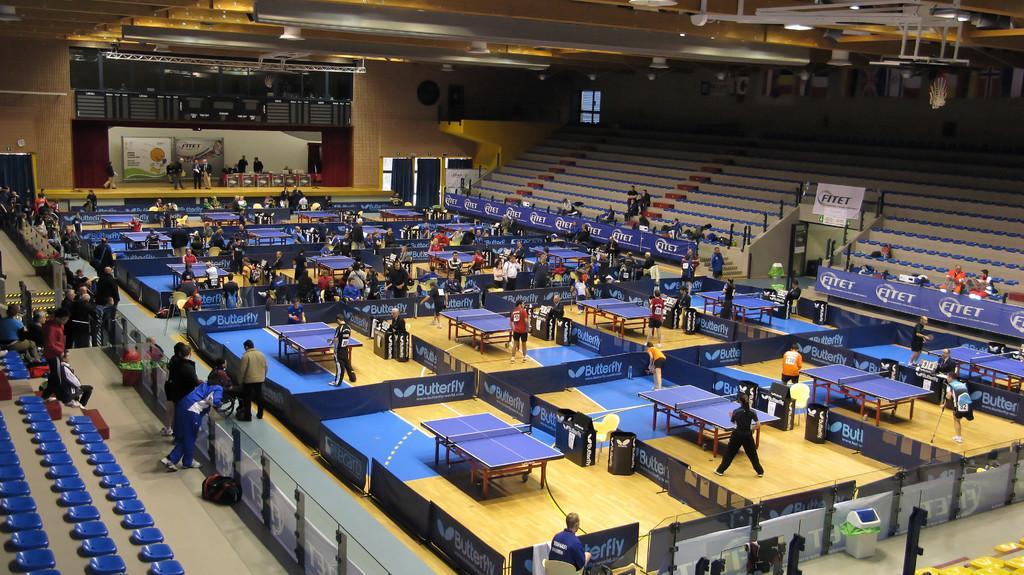In one or two sentences, can you explain what this image depicts? There is an auditorium in which there are many table tennis sections. People are present. There are blue seats at the left and right. There is a trash bin at the front. There are curtains at the left and right back. There is a stage at the back on which people are present. There is a window at the back. There are boards at the right. 